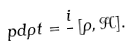<formula> <loc_0><loc_0><loc_500><loc_500>\ p d { \rho } { t } = \frac { i } { } \, [ \rho , \mathcal { H } ] .</formula> 